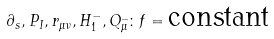Convert formula to latex. <formula><loc_0><loc_0><loc_500><loc_500>\partial _ { s } , P _ { I } , r _ { \mu \nu } , H _ { 1 } ^ { - } , Q _ { \mu } ^ { \_ } \colon f = \text {constant}</formula> 